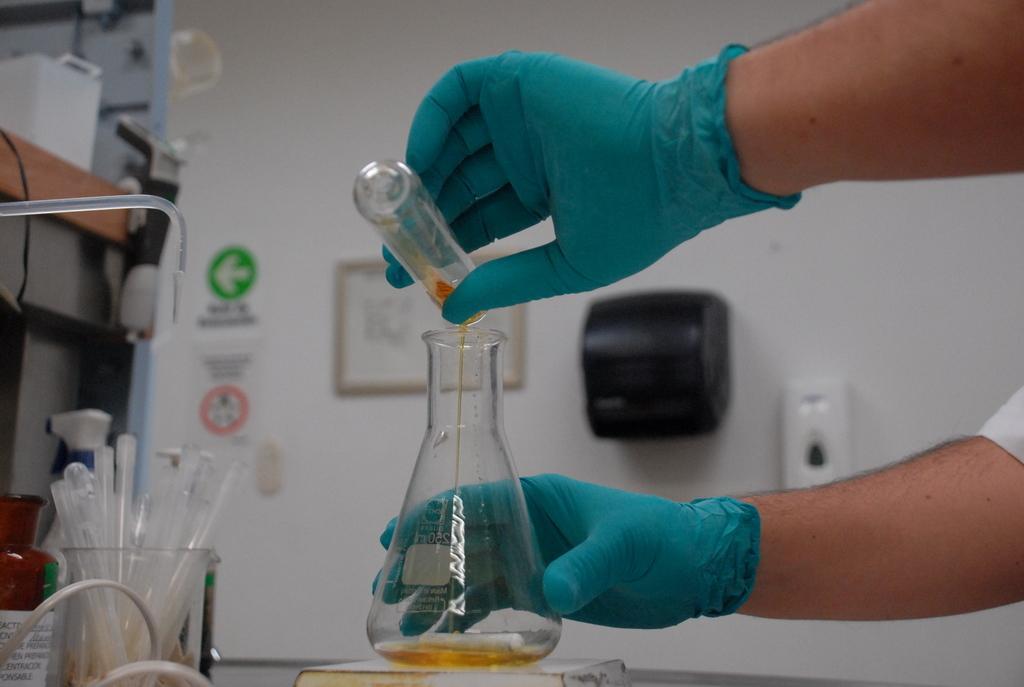Describe this image in one or two sentences. In this image we can see a person's hand wearing gloves and holding the glass bottle and the test tube in his hands. In the background, we can see few more test tubes, bottles, boards, photo frame on the wall and few more thing here. 